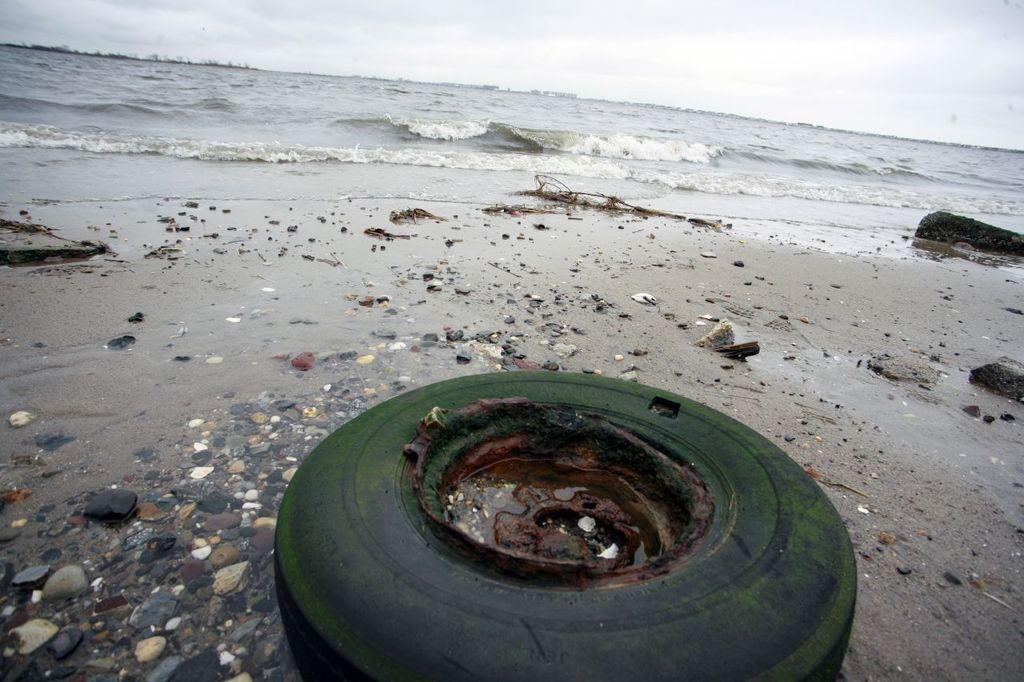What material is present at the bottom of the image? There is rusted iron at the bottom of the image. What is located near the rusted iron? There is water near the rusted iron. What type of large body of water can be seen in the image? There is a sea visible at the back side of the image. What is visible at the top of the image? The sky is visible at the top of the image. Where is the feast taking place in the image? There is no feast present in the image. Can you describe the nest that is visible in the image? There is no nest visible in the image. 